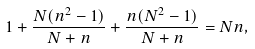Convert formula to latex. <formula><loc_0><loc_0><loc_500><loc_500>1 + \frac { N ( n ^ { 2 } - 1 ) } { N + n } + \frac { n ( N ^ { 2 } - 1 ) } { N + n } = N n ,</formula> 